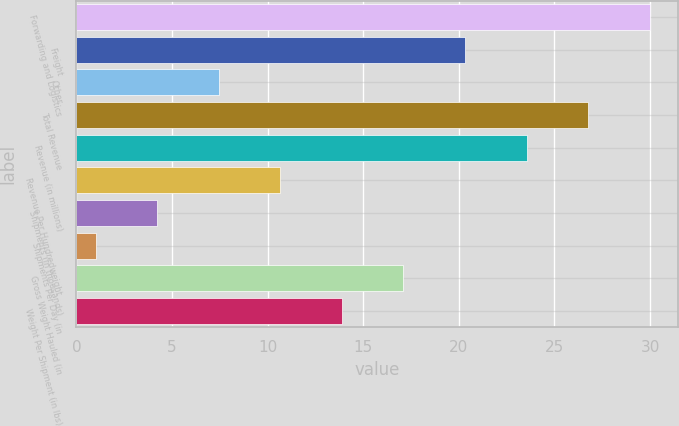<chart> <loc_0><loc_0><loc_500><loc_500><bar_chart><fcel>Forwarding and Logistics<fcel>Freight<fcel>Other<fcel>Total Revenue<fcel>Revenue (in millions)<fcel>Revenue Per Hundredweight<fcel>Shipments (in thousands)<fcel>Shipments Per Day (in<fcel>Gross Weight Hauled (in<fcel>Weight Per Shipment (in lbs)<nl><fcel>29.98<fcel>20.32<fcel>7.44<fcel>26.76<fcel>23.54<fcel>10.66<fcel>4.22<fcel>1<fcel>17.1<fcel>13.88<nl></chart> 